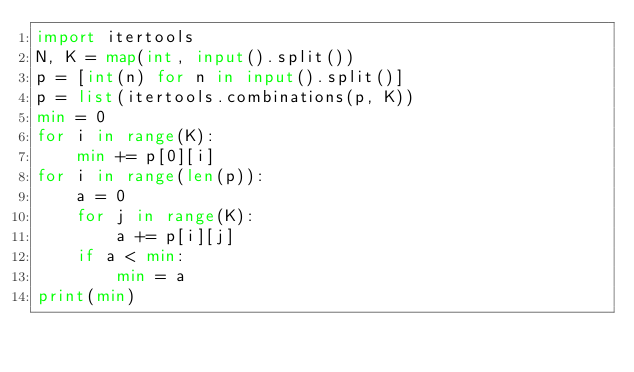Convert code to text. <code><loc_0><loc_0><loc_500><loc_500><_Python_>import itertools
N, K = map(int, input().split())
p = [int(n) for n in input().split()]
p = list(itertools.combinations(p, K))
min = 0
for i in range(K):
    min += p[0][i]
for i in range(len(p)):
    a = 0
    for j in range(K):
        a += p[i][j]
    if a < min:
        min = a
print(min)</code> 